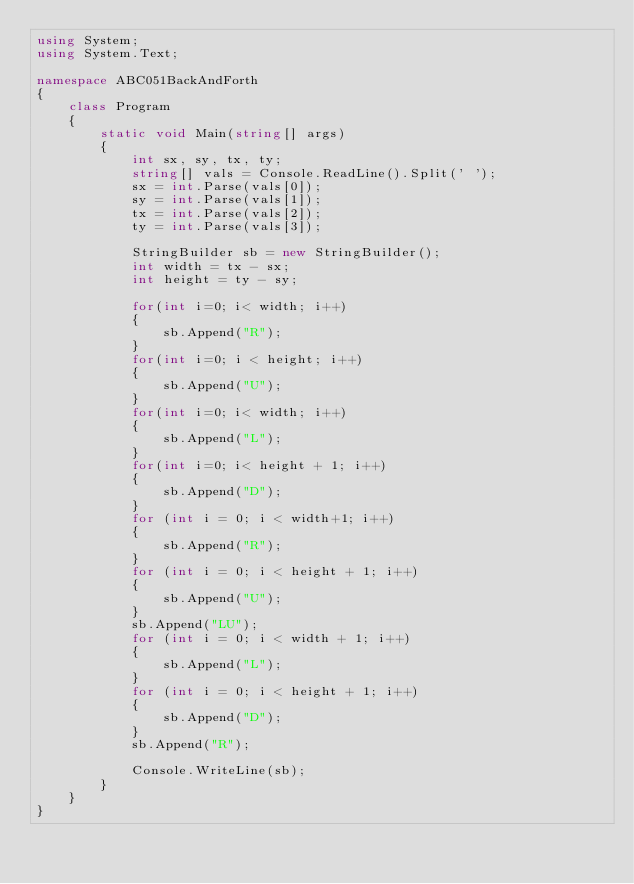<code> <loc_0><loc_0><loc_500><loc_500><_C#_>using System;
using System.Text;

namespace ABC051BackAndForth
{
    class Program
    {
        static void Main(string[] args)
        {
            int sx, sy, tx, ty;
            string[] vals = Console.ReadLine().Split(' ');
            sx = int.Parse(vals[0]);
            sy = int.Parse(vals[1]);
            tx = int.Parse(vals[2]);
            ty = int.Parse(vals[3]);

            StringBuilder sb = new StringBuilder();
            int width = tx - sx;
            int height = ty - sy;

            for(int i=0; i< width; i++)
            {
                sb.Append("R");
            }
            for(int i=0; i < height; i++)
            {
                sb.Append("U");
            }
            for(int i=0; i< width; i++)
            {
                sb.Append("L");
            }
            for(int i=0; i< height + 1; i++)
            {
                sb.Append("D");
            }
            for (int i = 0; i < width+1; i++)
            {
                sb.Append("R");
            }
            for (int i = 0; i < height + 1; i++)
            {
                sb.Append("U");
            }
            sb.Append("LU");
            for (int i = 0; i < width + 1; i++)
            {
                sb.Append("L");
            }
            for (int i = 0; i < height + 1; i++)
            {
                sb.Append("D");
            }
            sb.Append("R");

            Console.WriteLine(sb);
        }
    }
}
</code> 